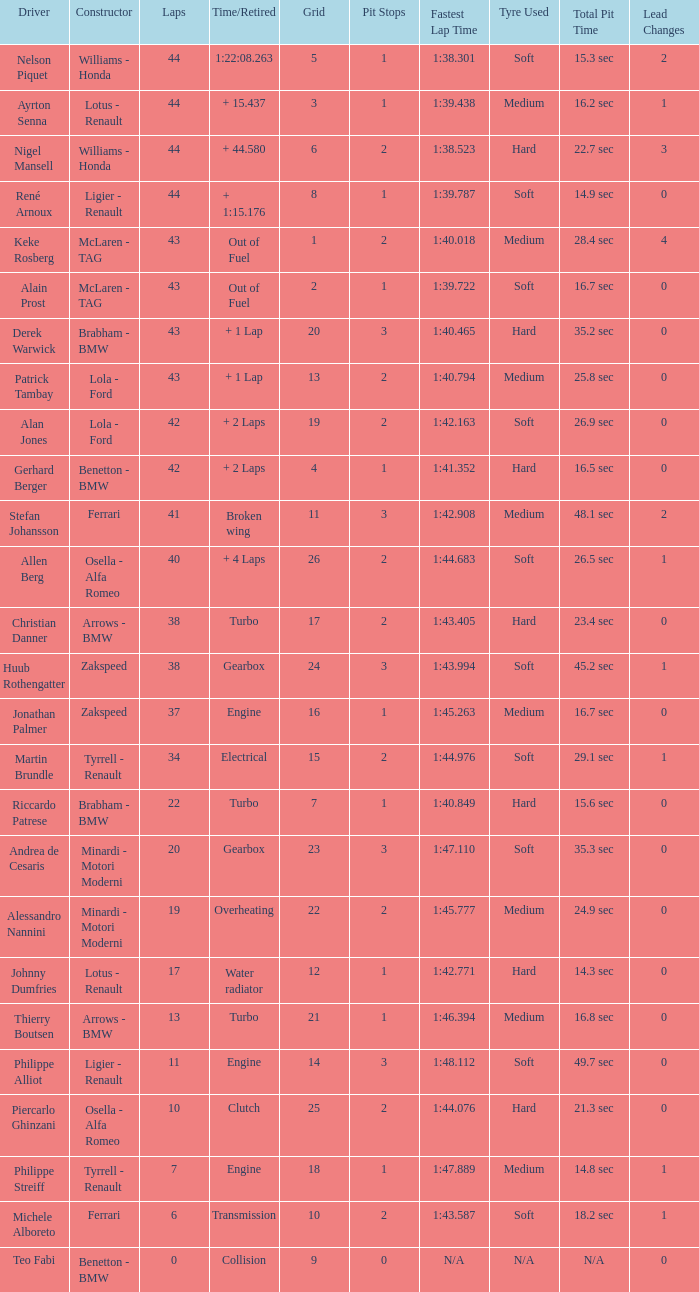I want the driver that has Laps of 10 Piercarlo Ghinzani. 